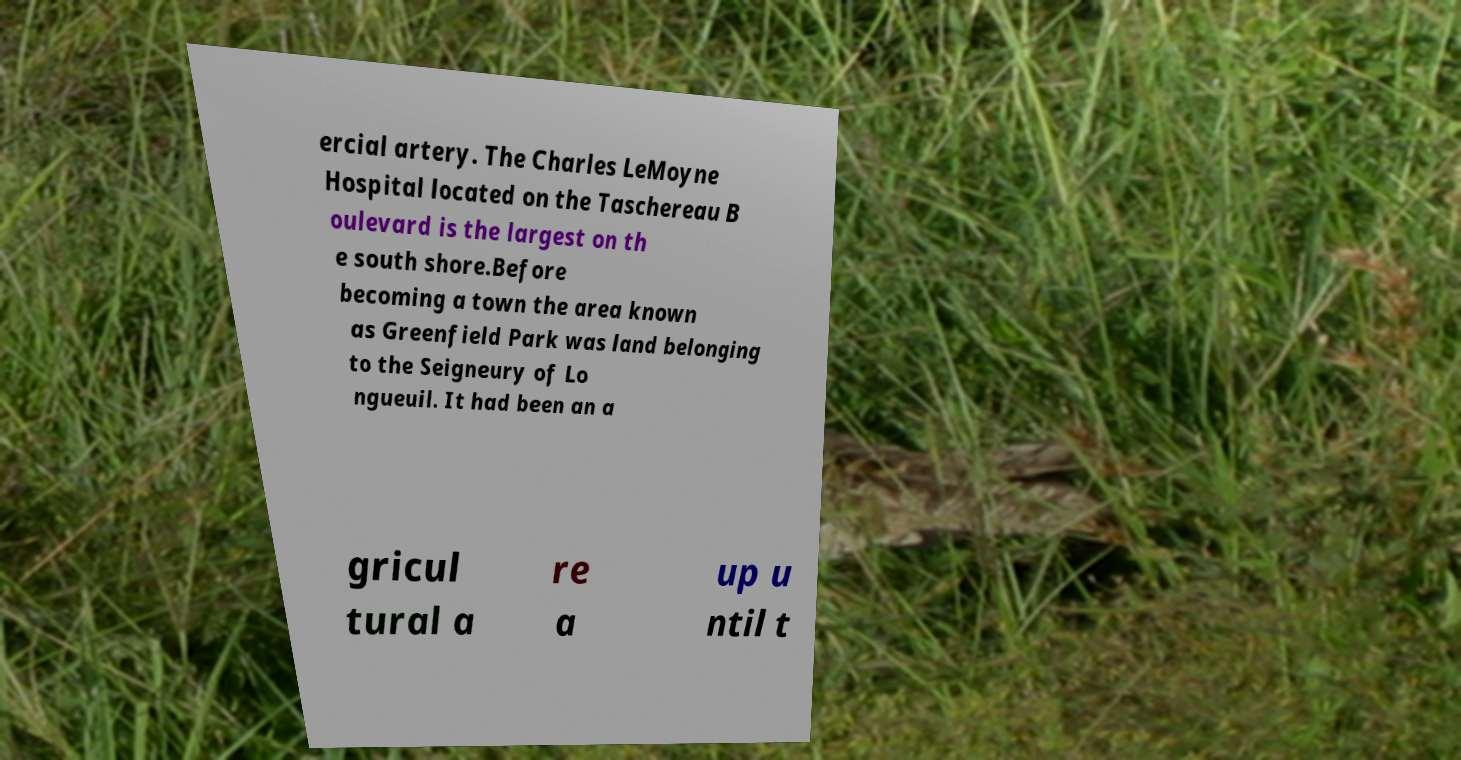I need the written content from this picture converted into text. Can you do that? ercial artery. The Charles LeMoyne Hospital located on the Taschereau B oulevard is the largest on th e south shore.Before becoming a town the area known as Greenfield Park was land belonging to the Seigneury of Lo ngueuil. It had been an a gricul tural a re a up u ntil t 